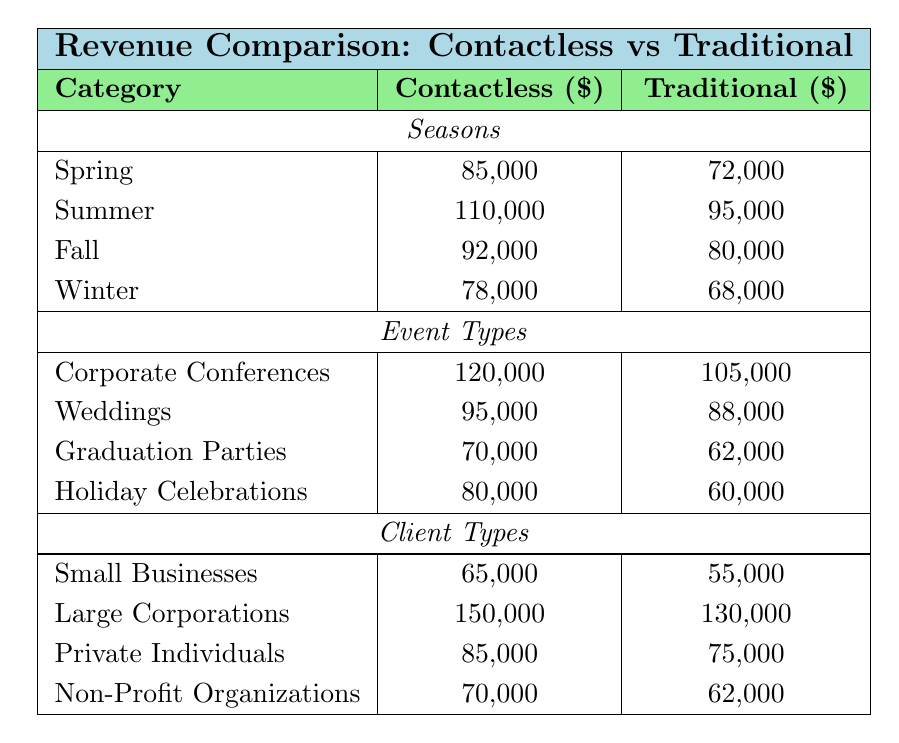What is the total revenue from Contactless catering in Spring? From the table, the Contactless revenue in Spring is indicated as 85,000.
Answer: 85,000 Which season had the highest revenue for Traditional catering? Looking at the "Traditional" row, the highest value is in Summer at 95,000.
Answer: Summer What is the difference in revenue between Contactless and Traditional methods for Fall? The Contactless revenue for Fall is 92,000 and the Traditional revenue is 80,000. The difference is 92,000 - 80,000 = 12,000.
Answer: 12,000 How much more revenue did Contactless catering generate than Traditional catering in Winter? The Contactless revenue for Winter is 78,000, and the Traditional revenue is 68,000. The difference is 78,000 - 68,000 = 10,000.
Answer: 10,000 Which catering method earned more, on average, across all seasons? Adding Contactless revenue across all seasons gives 85,000 + 110,000 + 92,000 + 78,000 = 365,000. For Traditional, the sum is 72,000 + 95,000 + 80,000 + 68,000 = 315,000. The averages are 365,000 / 4 = 91,250 for Contactless and 315,000 / 4 = 78,750 for Traditional. Contactless has the higher average revenue.
Answer: Contactless How does the Contactless revenue for Corporate Conferences compare to the Traditional revenue for the same event type? The Contactless revenue for Corporate Conferences is 120,000, while the Traditional revenue is 105,000. Contactless generated 15,000 more.
Answer: 15,000 For which client type is the revenue for Contactless catering highest? The "Large Corporations" category has the highest Contactless revenue at 150,000 compared to others like Small Businesses (65,000), Private Individuals (85,000), and Non-Profit Organizations (70,000).
Answer: Large Corporations What is the total revenue from Traditional catering for all seasons combined? Adding the Traditional revenues for all seasons gives 72,000 + 95,000 + 80,000 + 68,000 = 315,000.
Answer: 315,000 Is the revenue from Contactless catering for Weddings greater than the revenue for Graduation Parties using the Traditional method? Contactless revenue for Weddings is 95,000 and Traditional revenue for Graduation Parties is 62,000. Since 95,000 > 62,000, the statement is true.
Answer: Yes What is the percentage increase in revenue for Contactless catering from Winter to Spring? Contactless revenue in Winter is 78,000 and in Spring it is 85,000. The increase is 85,000 - 78,000 = 7,000. The percentage increase is (7,000 / 78,000) * 100 ≈ 8.97%.
Answer: ~8.97% 